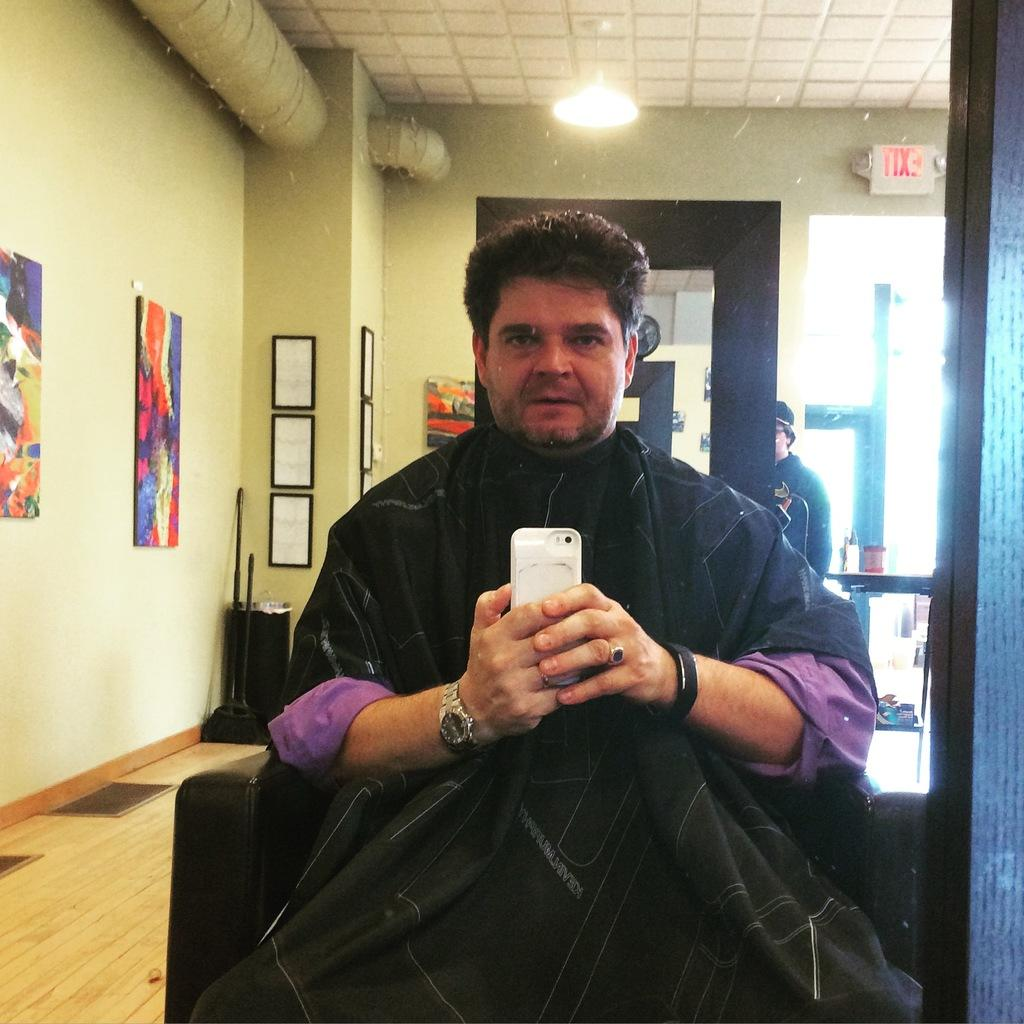What is the person in the image doing? The person is sitting on a chair in the image. What object is the person holding? The person is holding a mobile phone. What can be seen in the background of the image? There are photo frames, a door, a light, a mirror, and a wall in the background of the image. What type of pancake is being cooked in the image? There is no pancake present in the image. How does the carriage fit into the scene depicted in the image? There is no carriage present in the image. 